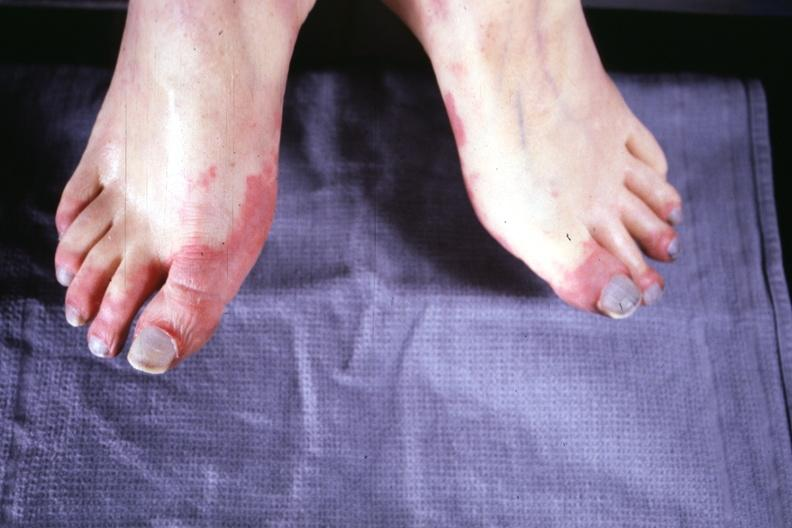what are present?
Answer the question using a single word or phrase. Extremities 